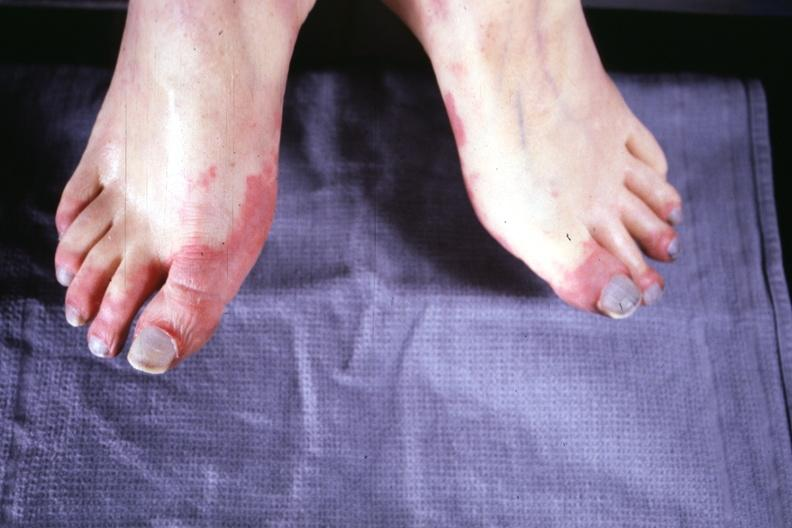what are present?
Answer the question using a single word or phrase. Extremities 